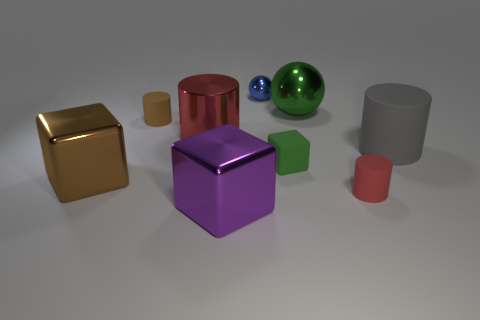Subtract all brown cylinders. How many cylinders are left? 3 Subtract all large red cylinders. How many cylinders are left? 3 Add 1 red shiny spheres. How many objects exist? 10 Subtract all cyan cylinders. Subtract all brown spheres. How many cylinders are left? 4 Subtract all cylinders. How many objects are left? 5 Add 5 big green metal spheres. How many big green metal spheres exist? 6 Subtract 0 gray blocks. How many objects are left? 9 Subtract all green matte cubes. Subtract all blue things. How many objects are left? 7 Add 8 green objects. How many green objects are left? 10 